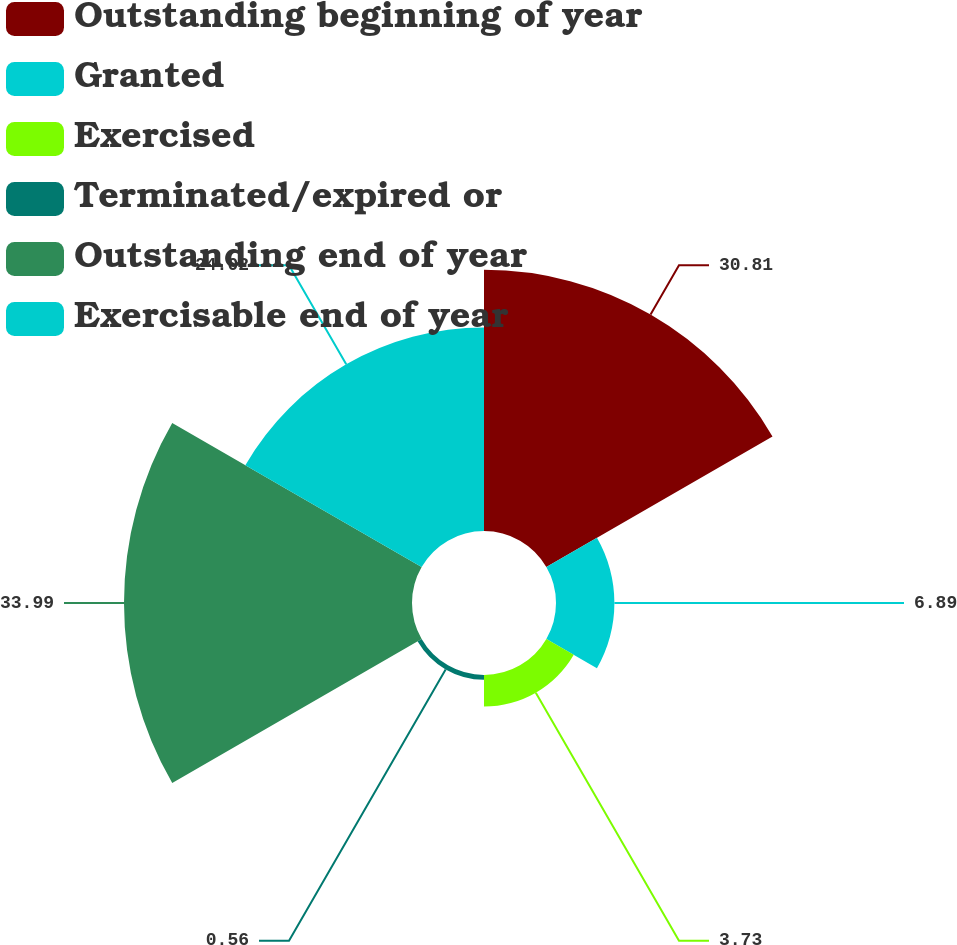Convert chart to OTSL. <chart><loc_0><loc_0><loc_500><loc_500><pie_chart><fcel>Outstanding beginning of year<fcel>Granted<fcel>Exercised<fcel>Terminated/expired or<fcel>Outstanding end of year<fcel>Exercisable end of year<nl><fcel>30.81%<fcel>6.89%<fcel>3.73%<fcel>0.56%<fcel>33.98%<fcel>24.02%<nl></chart> 